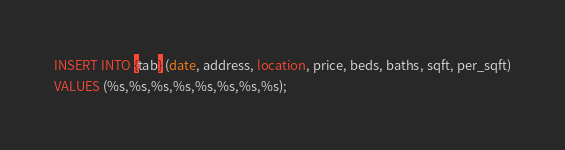<code> <loc_0><loc_0><loc_500><loc_500><_SQL_>INSERT INTO {tab} (date, address, location, price, beds, baths, sqft, per_sqft)
VALUES (%s,%s,%s,%s,%s,%s,%s,%s);</code> 